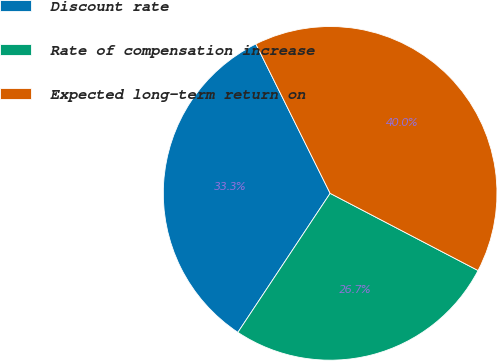Convert chart. <chart><loc_0><loc_0><loc_500><loc_500><pie_chart><fcel>Discount rate<fcel>Rate of compensation increase<fcel>Expected long-term return on<nl><fcel>33.33%<fcel>26.67%<fcel>40.0%<nl></chart> 